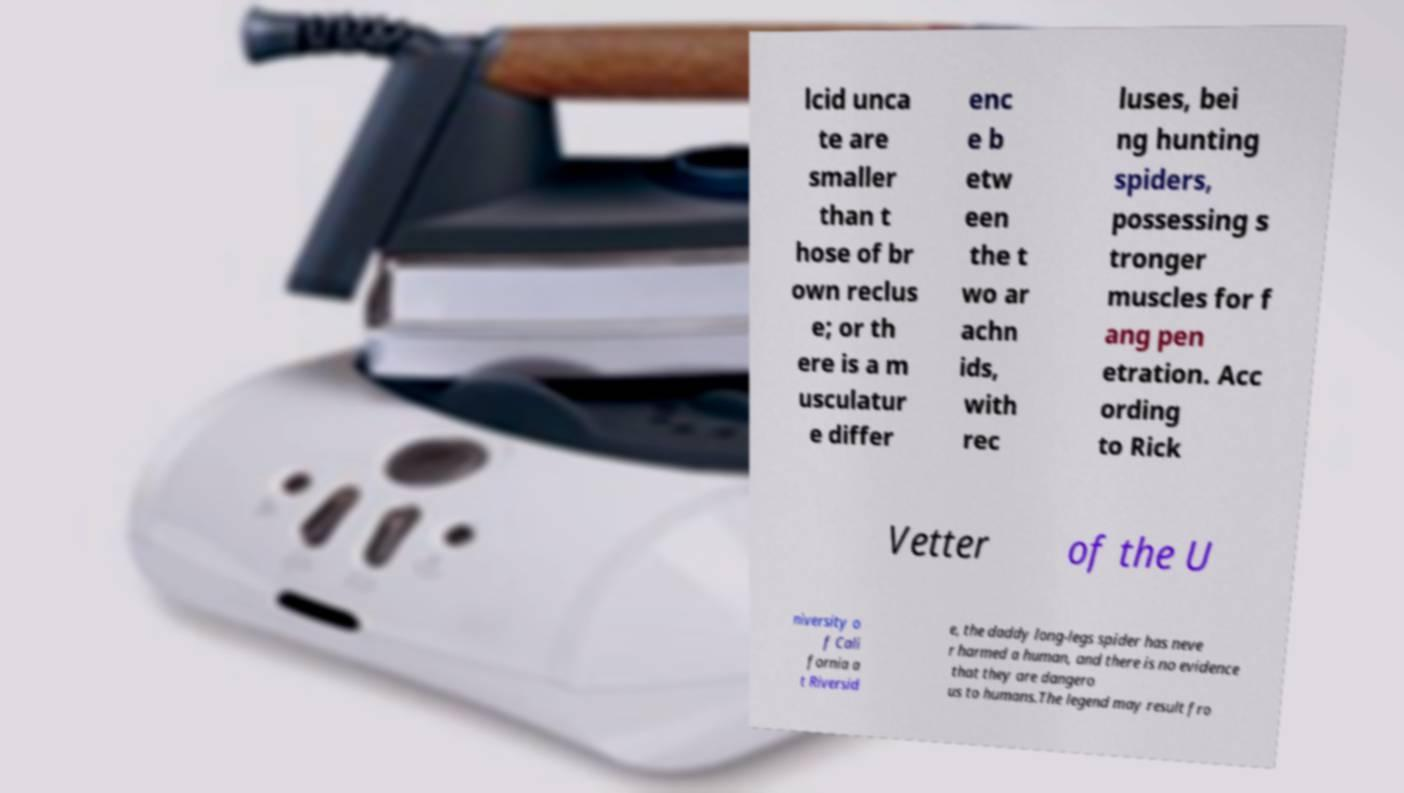Please identify and transcribe the text found in this image. lcid unca te are smaller than t hose of br own reclus e; or th ere is a m usculatur e differ enc e b etw een the t wo ar achn ids, with rec luses, bei ng hunting spiders, possessing s tronger muscles for f ang pen etration. Acc ording to Rick Vetter of the U niversity o f Cali fornia a t Riversid e, the daddy long-legs spider has neve r harmed a human, and there is no evidence that they are dangero us to humans.The legend may result fro 